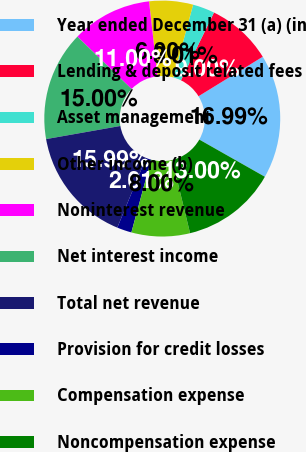Convert chart to OTSL. <chart><loc_0><loc_0><loc_500><loc_500><pie_chart><fcel>Year ended December 31 (a) (in<fcel>Lending & deposit related fees<fcel>Asset management<fcel>Other income (b)<fcel>Noninterest revenue<fcel>Net interest income<fcel>Total net revenue<fcel>Provision for credit losses<fcel>Compensation expense<fcel>Noncompensation expense<nl><fcel>16.99%<fcel>9.0%<fcel>3.01%<fcel>6.0%<fcel>11.0%<fcel>15.0%<fcel>15.99%<fcel>2.01%<fcel>8.0%<fcel>13.0%<nl></chart> 